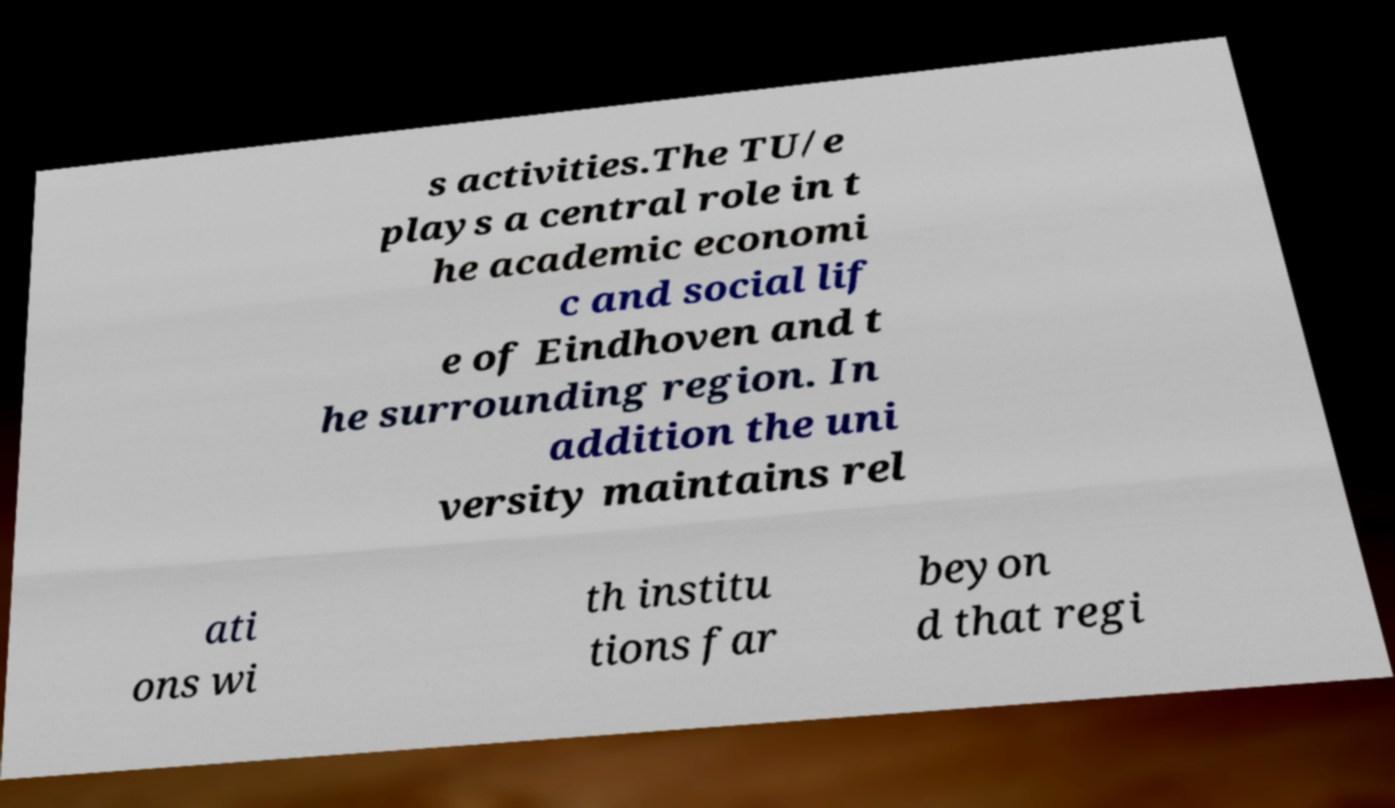Can you read and provide the text displayed in the image?This photo seems to have some interesting text. Can you extract and type it out for me? s activities.The TU/e plays a central role in t he academic economi c and social lif e of Eindhoven and t he surrounding region. In addition the uni versity maintains rel ati ons wi th institu tions far beyon d that regi 